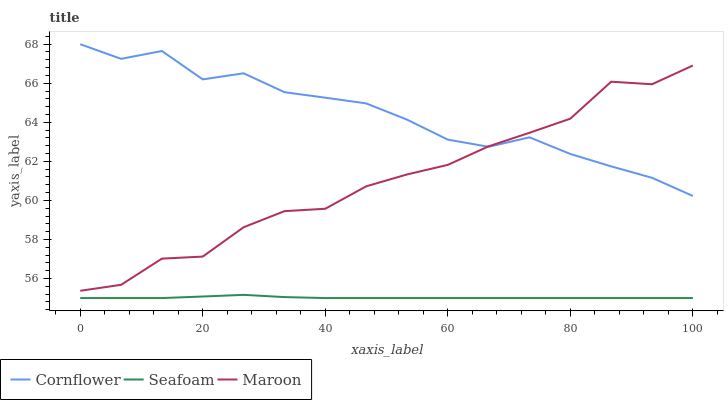Does Seafoam have the minimum area under the curve?
Answer yes or no. Yes. Does Cornflower have the maximum area under the curve?
Answer yes or no. Yes. Does Maroon have the minimum area under the curve?
Answer yes or no. No. Does Maroon have the maximum area under the curve?
Answer yes or no. No. Is Seafoam the smoothest?
Answer yes or no. Yes. Is Maroon the roughest?
Answer yes or no. Yes. Is Maroon the smoothest?
Answer yes or no. No. Is Seafoam the roughest?
Answer yes or no. No. Does Seafoam have the lowest value?
Answer yes or no. Yes. Does Maroon have the lowest value?
Answer yes or no. No. Does Cornflower have the highest value?
Answer yes or no. Yes. Does Maroon have the highest value?
Answer yes or no. No. Is Seafoam less than Cornflower?
Answer yes or no. Yes. Is Cornflower greater than Seafoam?
Answer yes or no. Yes. Does Maroon intersect Cornflower?
Answer yes or no. Yes. Is Maroon less than Cornflower?
Answer yes or no. No. Is Maroon greater than Cornflower?
Answer yes or no. No. Does Seafoam intersect Cornflower?
Answer yes or no. No. 